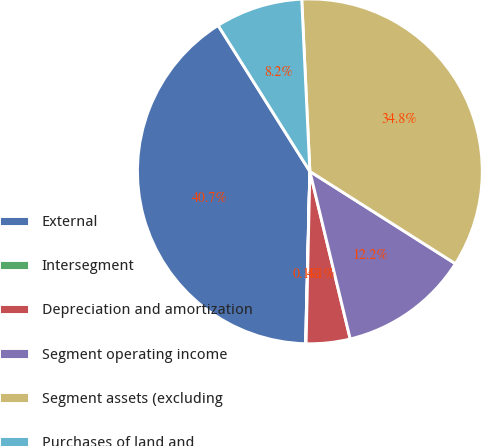Convert chart to OTSL. <chart><loc_0><loc_0><loc_500><loc_500><pie_chart><fcel>External<fcel>Intersegment<fcel>Depreciation and amortization<fcel>Segment operating income<fcel>Segment assets (excluding<fcel>Purchases of land and<nl><fcel>40.67%<fcel>0.05%<fcel>4.11%<fcel>12.24%<fcel>34.75%<fcel>8.18%<nl></chart> 